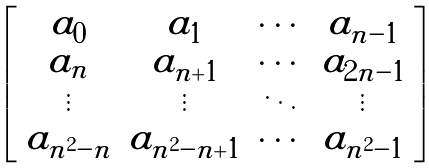Convert formula to latex. <formula><loc_0><loc_0><loc_500><loc_500>\left [ \begin{array} { c c c c } a _ { 0 } & a _ { 1 } & \cdots & a _ { n - 1 } \\ a _ { n } & a _ { n + 1 } & \cdots & a _ { 2 n - 1 } \\ \vdots & \vdots & \ddots & \vdots \\ a _ { n ^ { 2 } - n } & a _ { n ^ { 2 } - n + 1 } & \cdots & a _ { n ^ { 2 } - 1 } \end{array} \right ]</formula> 